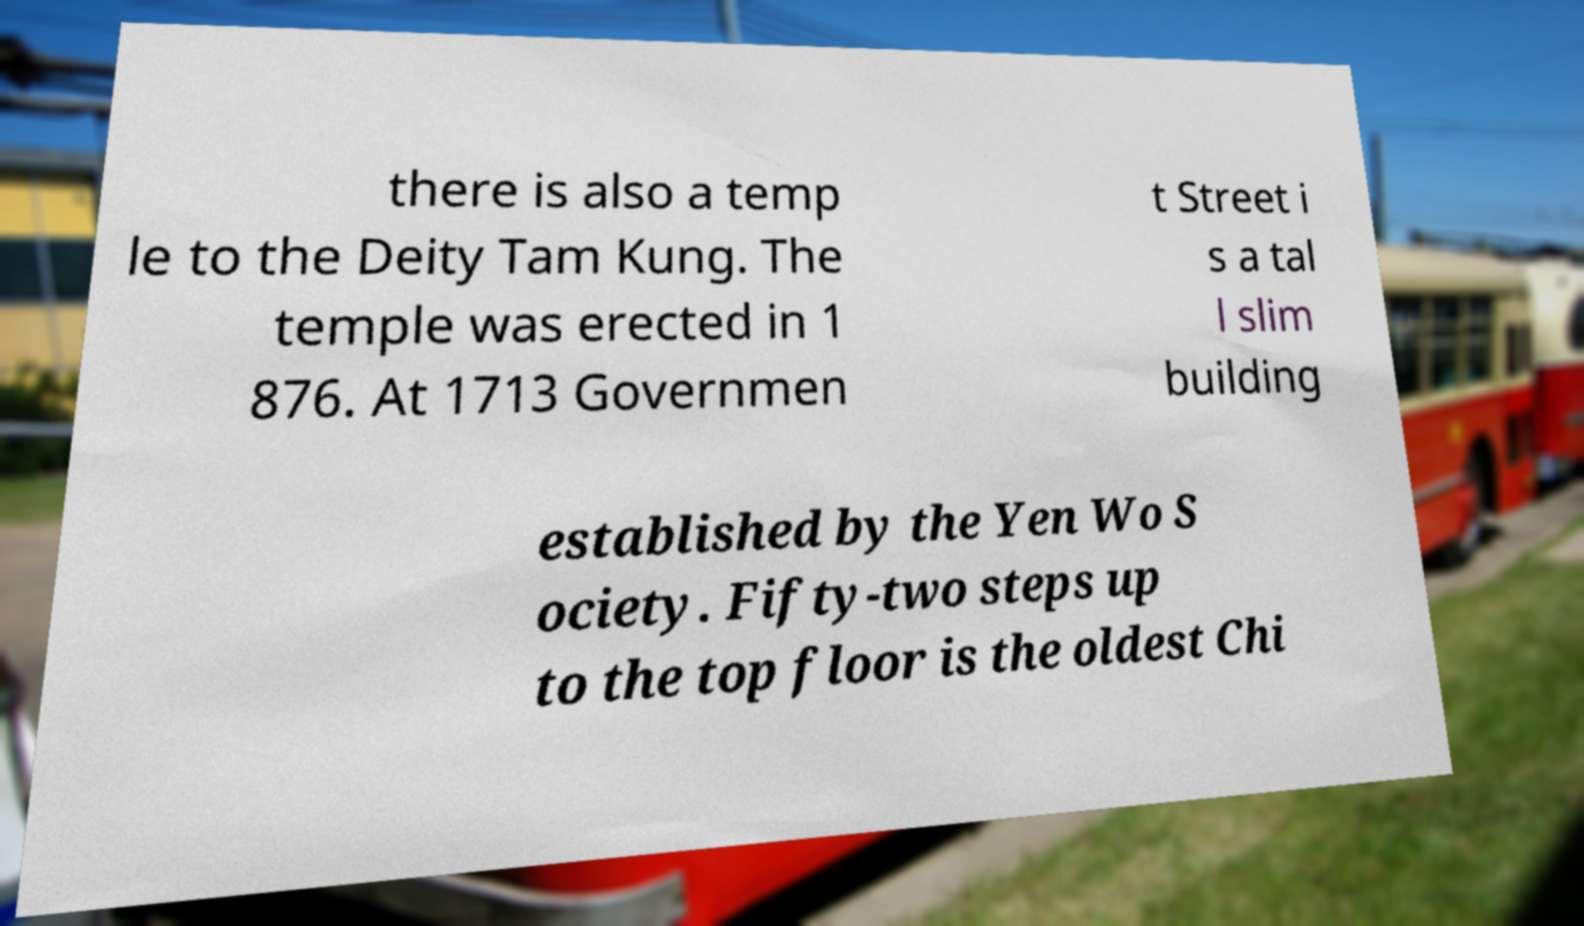Could you extract and type out the text from this image? there is also a temp le to the Deity Tam Kung. The temple was erected in 1 876. At 1713 Governmen t Street i s a tal l slim building established by the Yen Wo S ociety. Fifty-two steps up to the top floor is the oldest Chi 